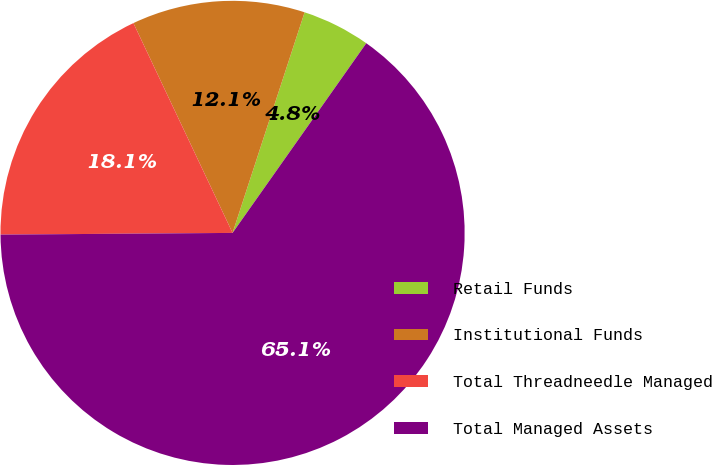Convert chart to OTSL. <chart><loc_0><loc_0><loc_500><loc_500><pie_chart><fcel>Retail Funds<fcel>Institutional Funds<fcel>Total Threadneedle Managed<fcel>Total Managed Assets<nl><fcel>4.75%<fcel>12.05%<fcel>18.09%<fcel>65.11%<nl></chart> 